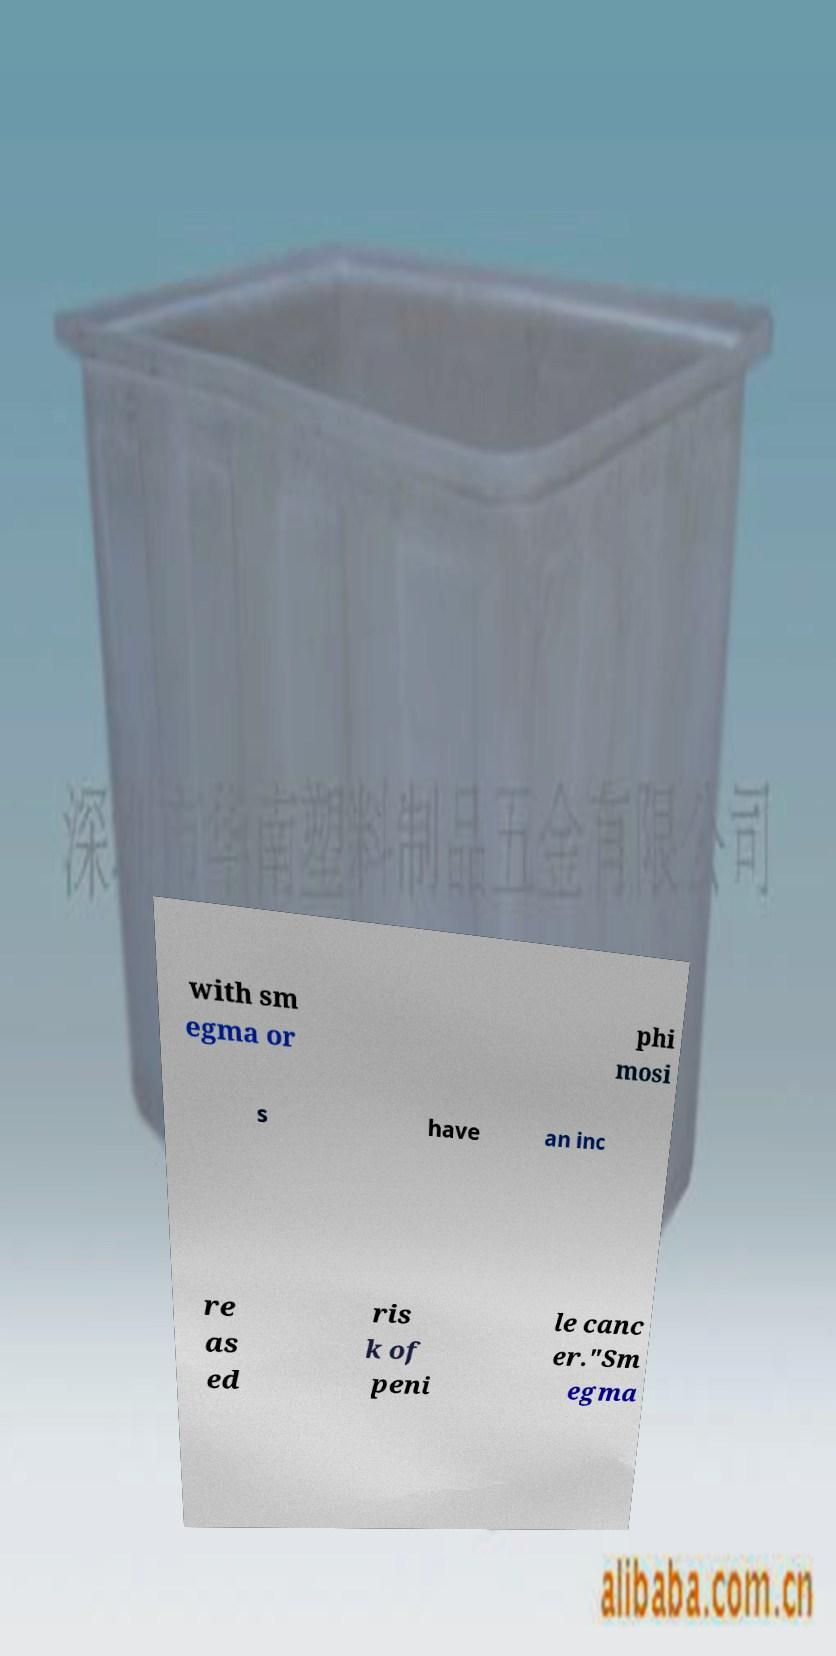Can you accurately transcribe the text from the provided image for me? with sm egma or phi mosi s have an inc re as ed ris k of peni le canc er."Sm egma 